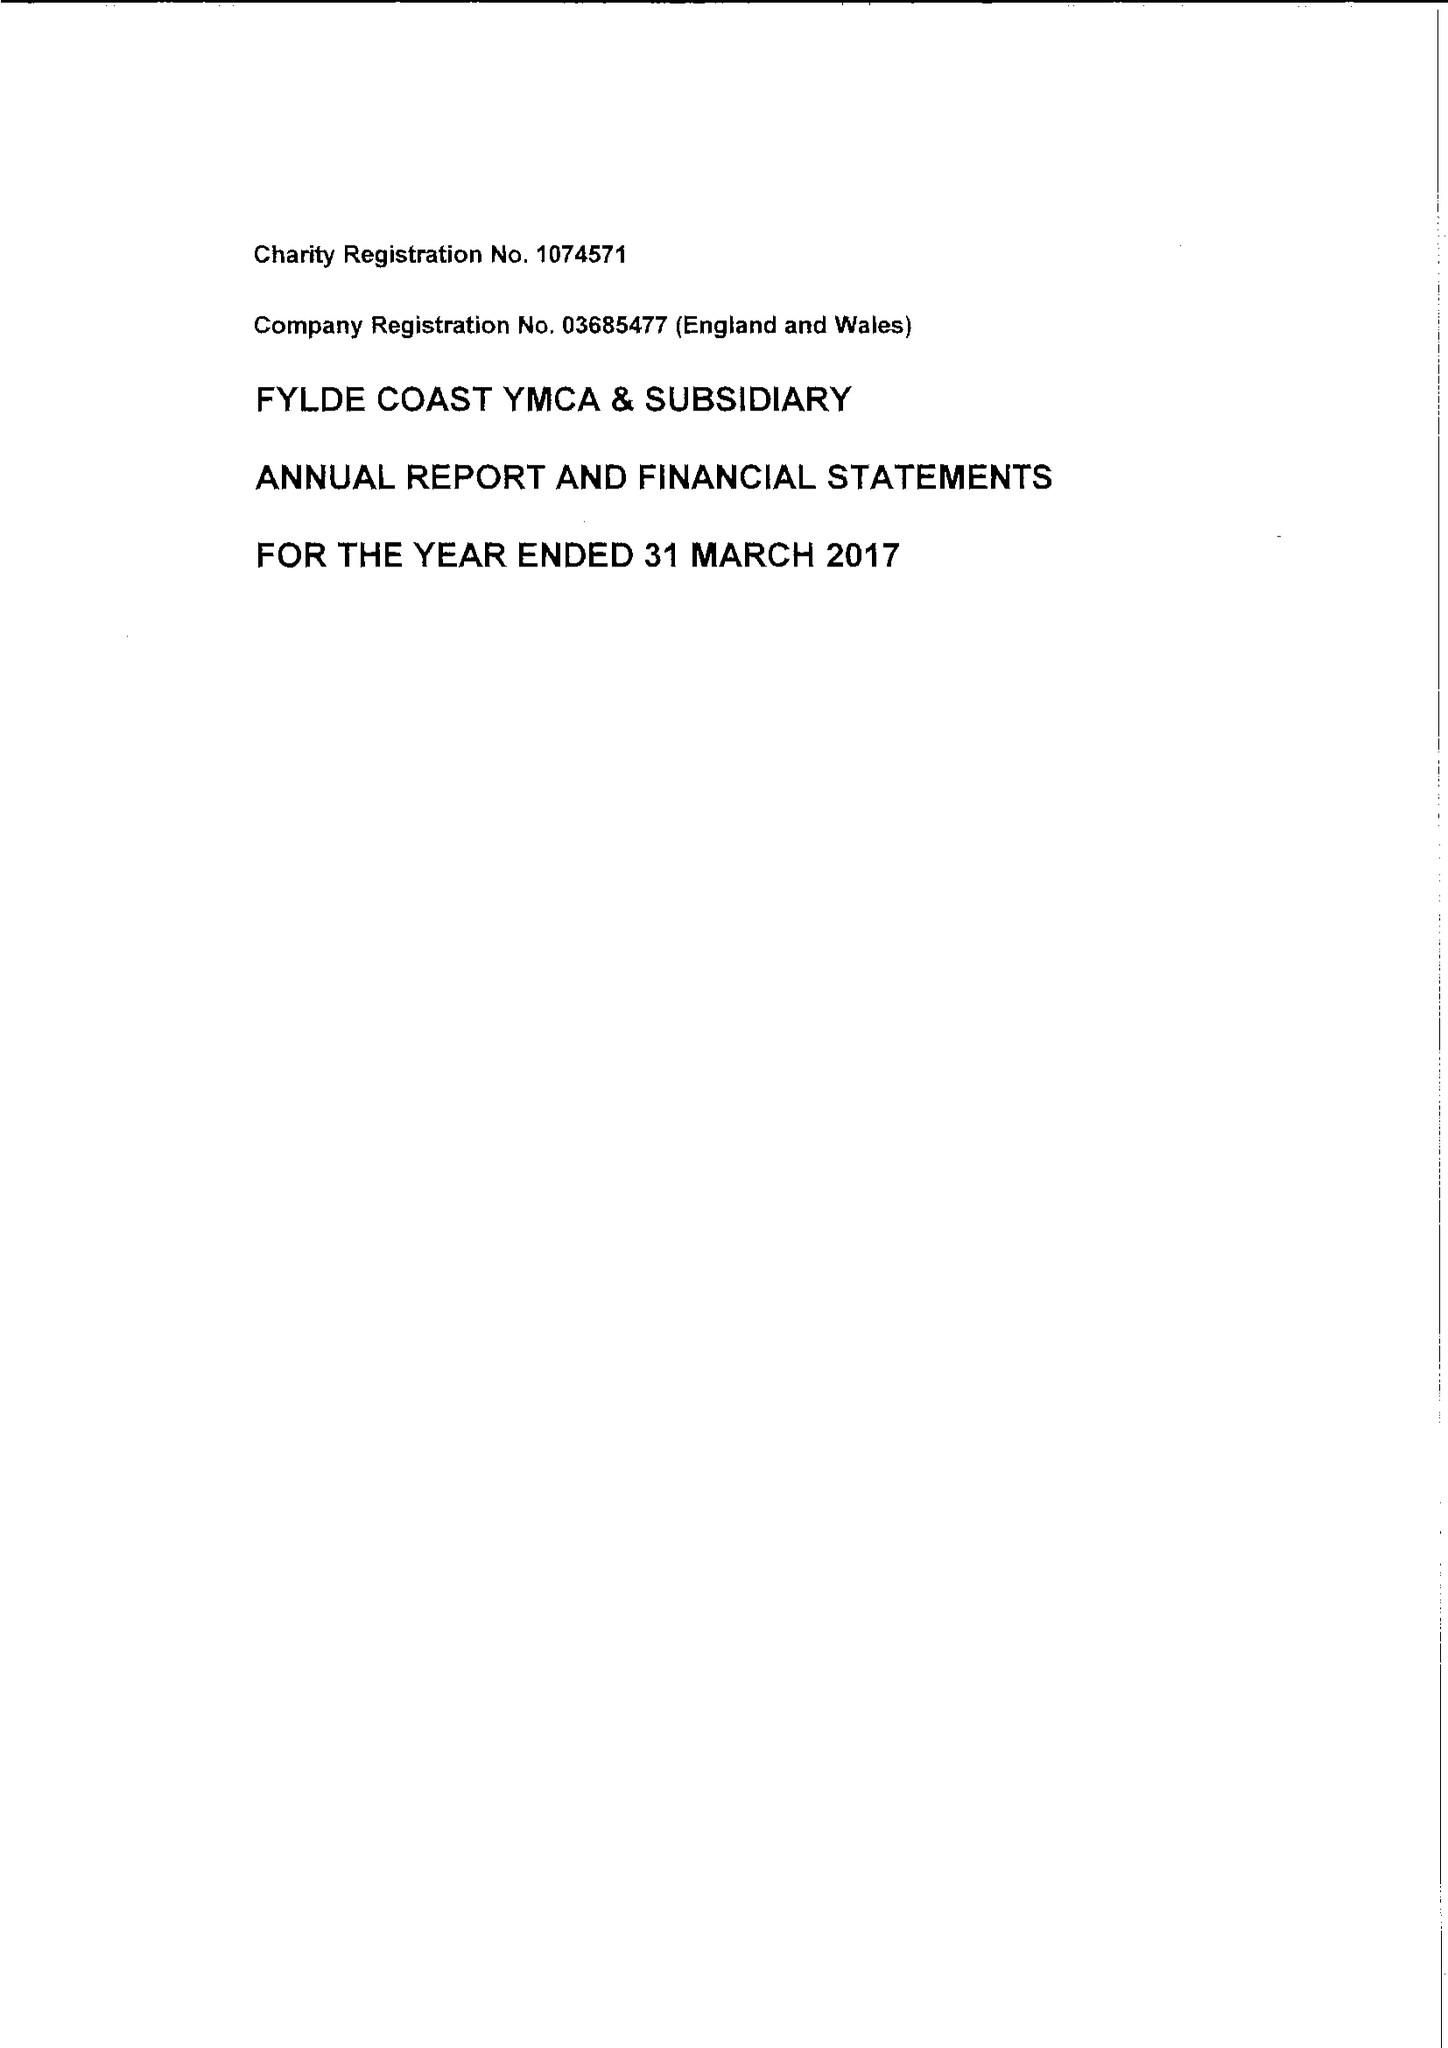What is the value for the address__street_line?
Answer the question using a single word or phrase. None 